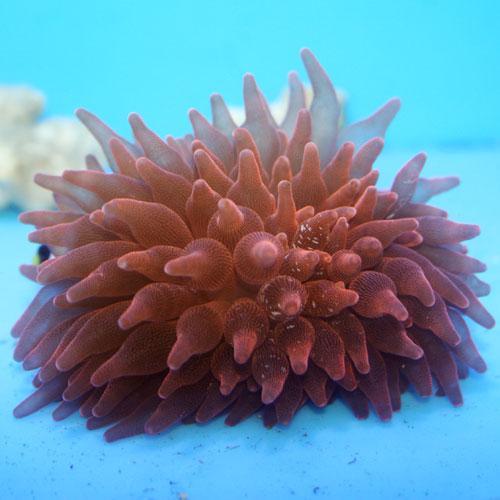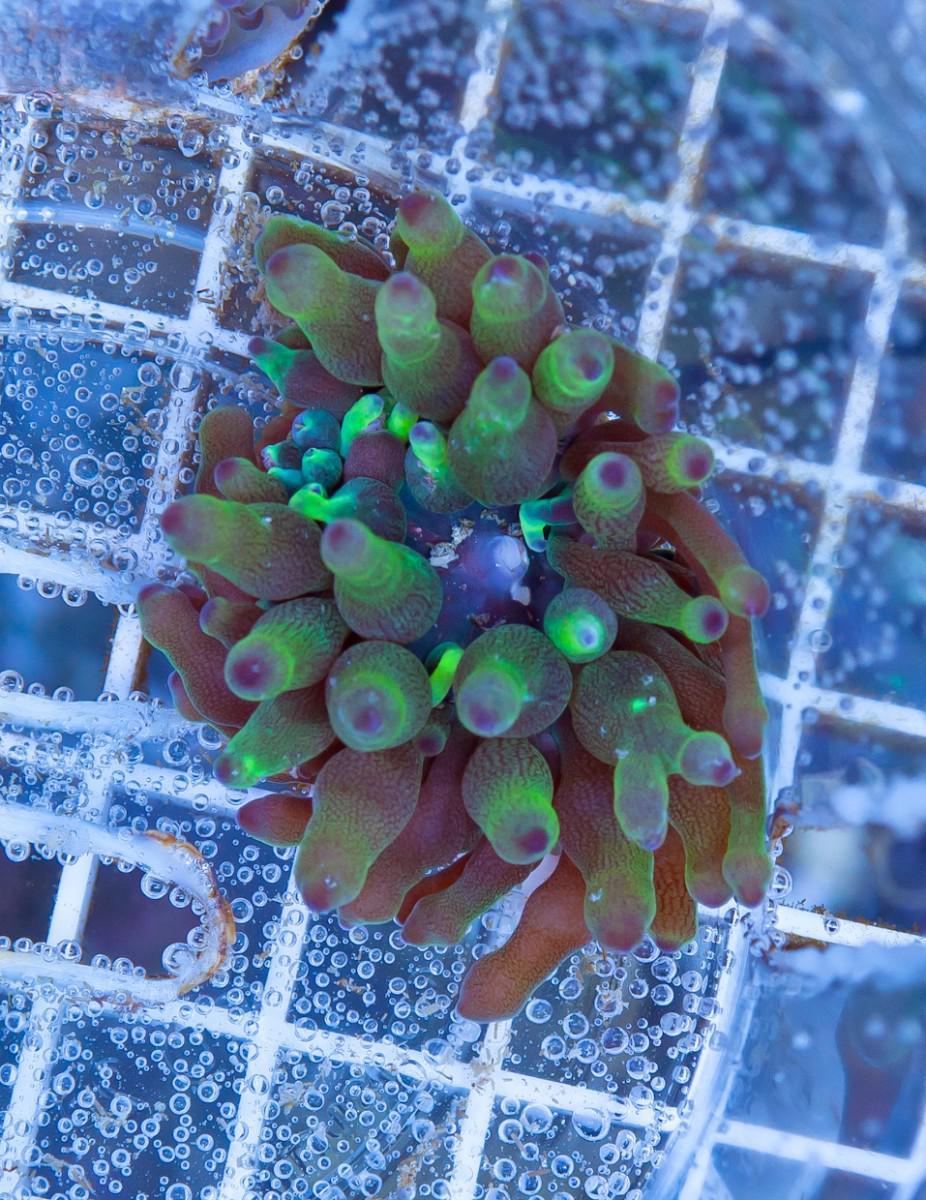The first image is the image on the left, the second image is the image on the right. Examine the images to the left and right. Is the description "There are only two anemones and at least one of them appears to be on a natural rock surface." accurate? Answer yes or no. No. 